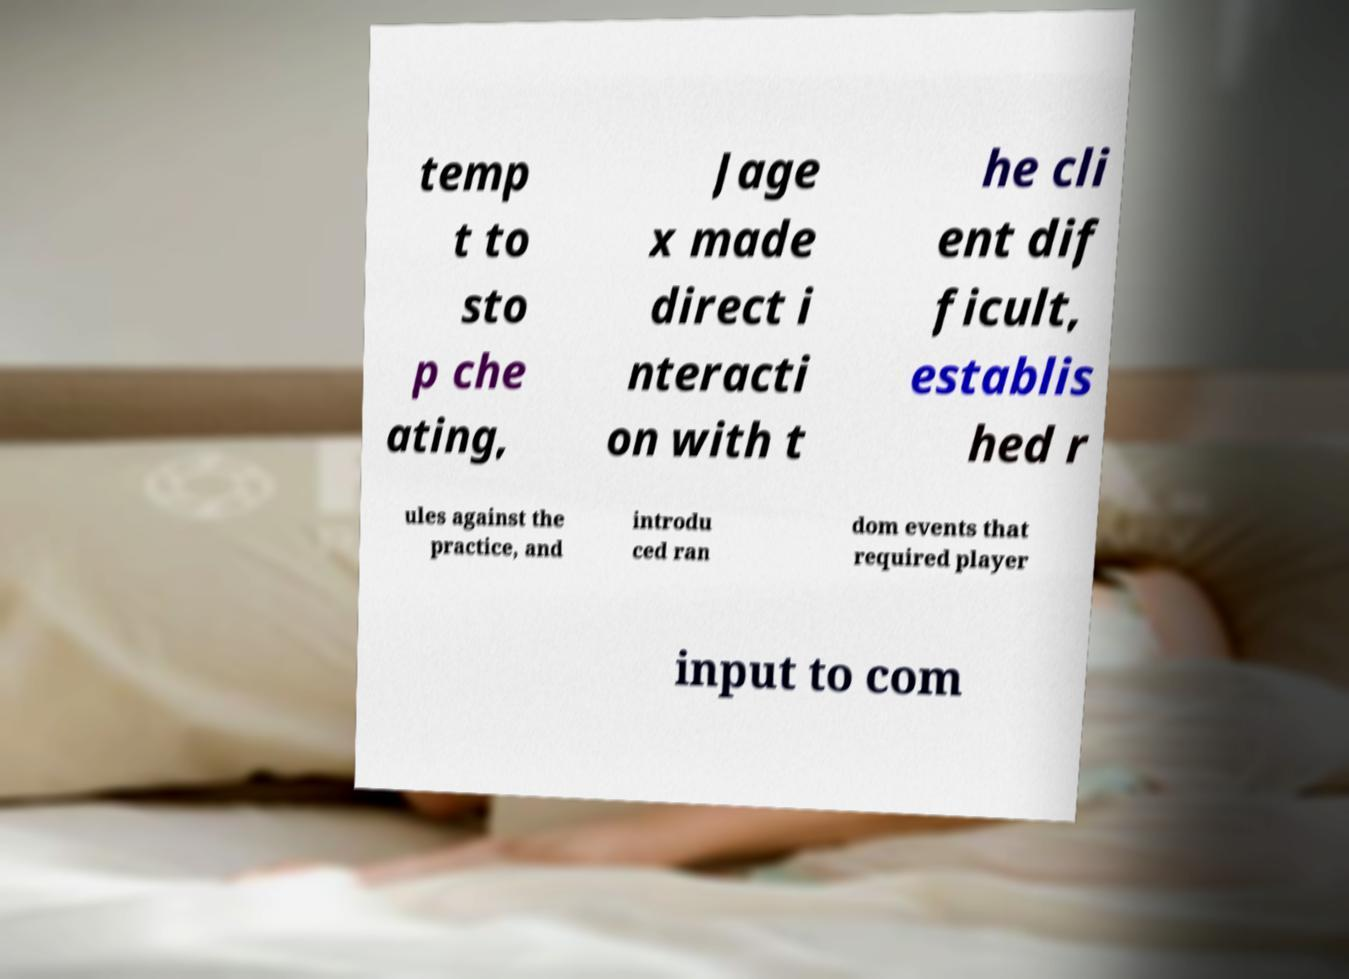Can you accurately transcribe the text from the provided image for me? temp t to sto p che ating, Jage x made direct i nteracti on with t he cli ent dif ficult, establis hed r ules against the practice, and introdu ced ran dom events that required player input to com 